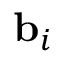<formula> <loc_0><loc_0><loc_500><loc_500>{ b } _ { i }</formula> 